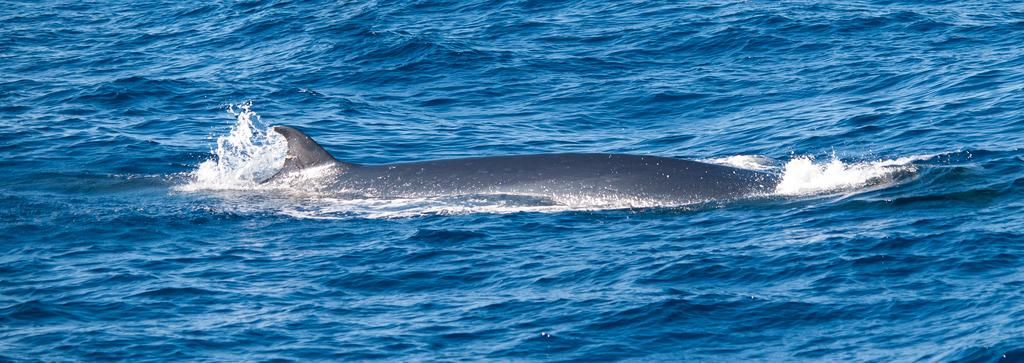What type of animal is in the image? There is a fish in the image. Where is the fish located in the image? The fish is on the surface of water. What type of business is being conducted on the hill in the image? There is no hill or business present in the image; it features a fish on the surface of water. 